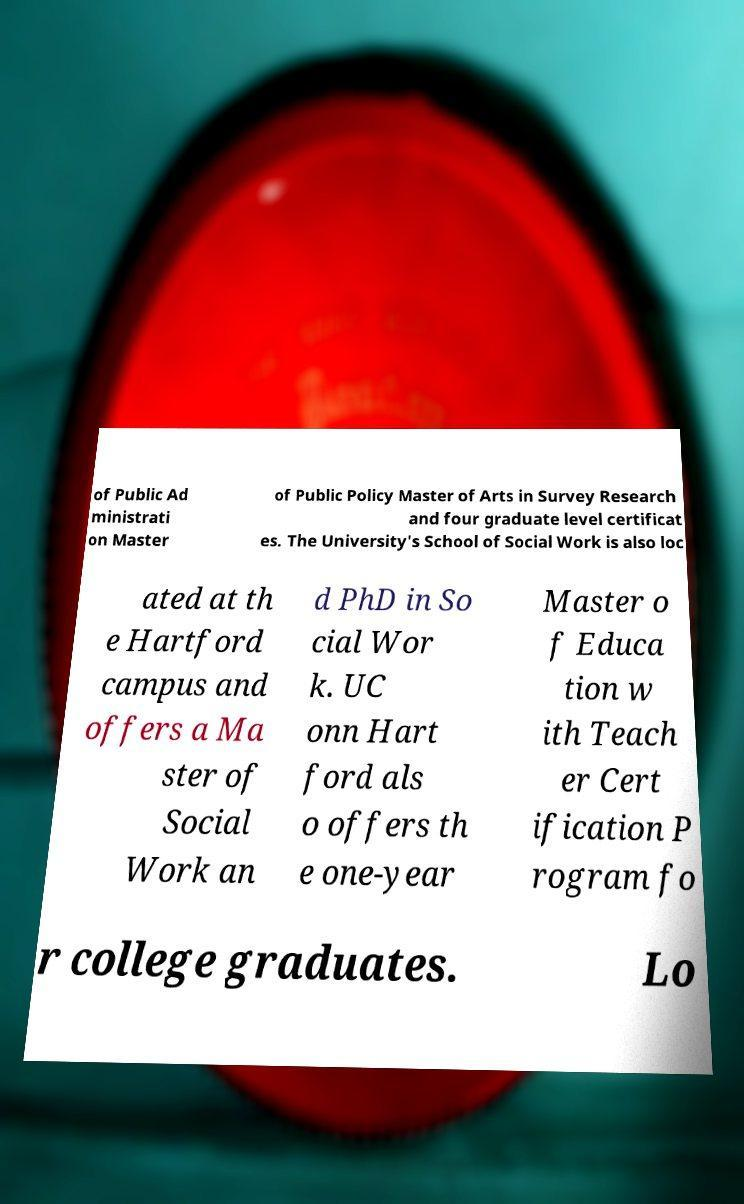What messages or text are displayed in this image? I need them in a readable, typed format. of Public Ad ministrati on Master of Public Policy Master of Arts in Survey Research and four graduate level certificat es. The University's School of Social Work is also loc ated at th e Hartford campus and offers a Ma ster of Social Work an d PhD in So cial Wor k. UC onn Hart ford als o offers th e one-year Master o f Educa tion w ith Teach er Cert ification P rogram fo r college graduates. Lo 